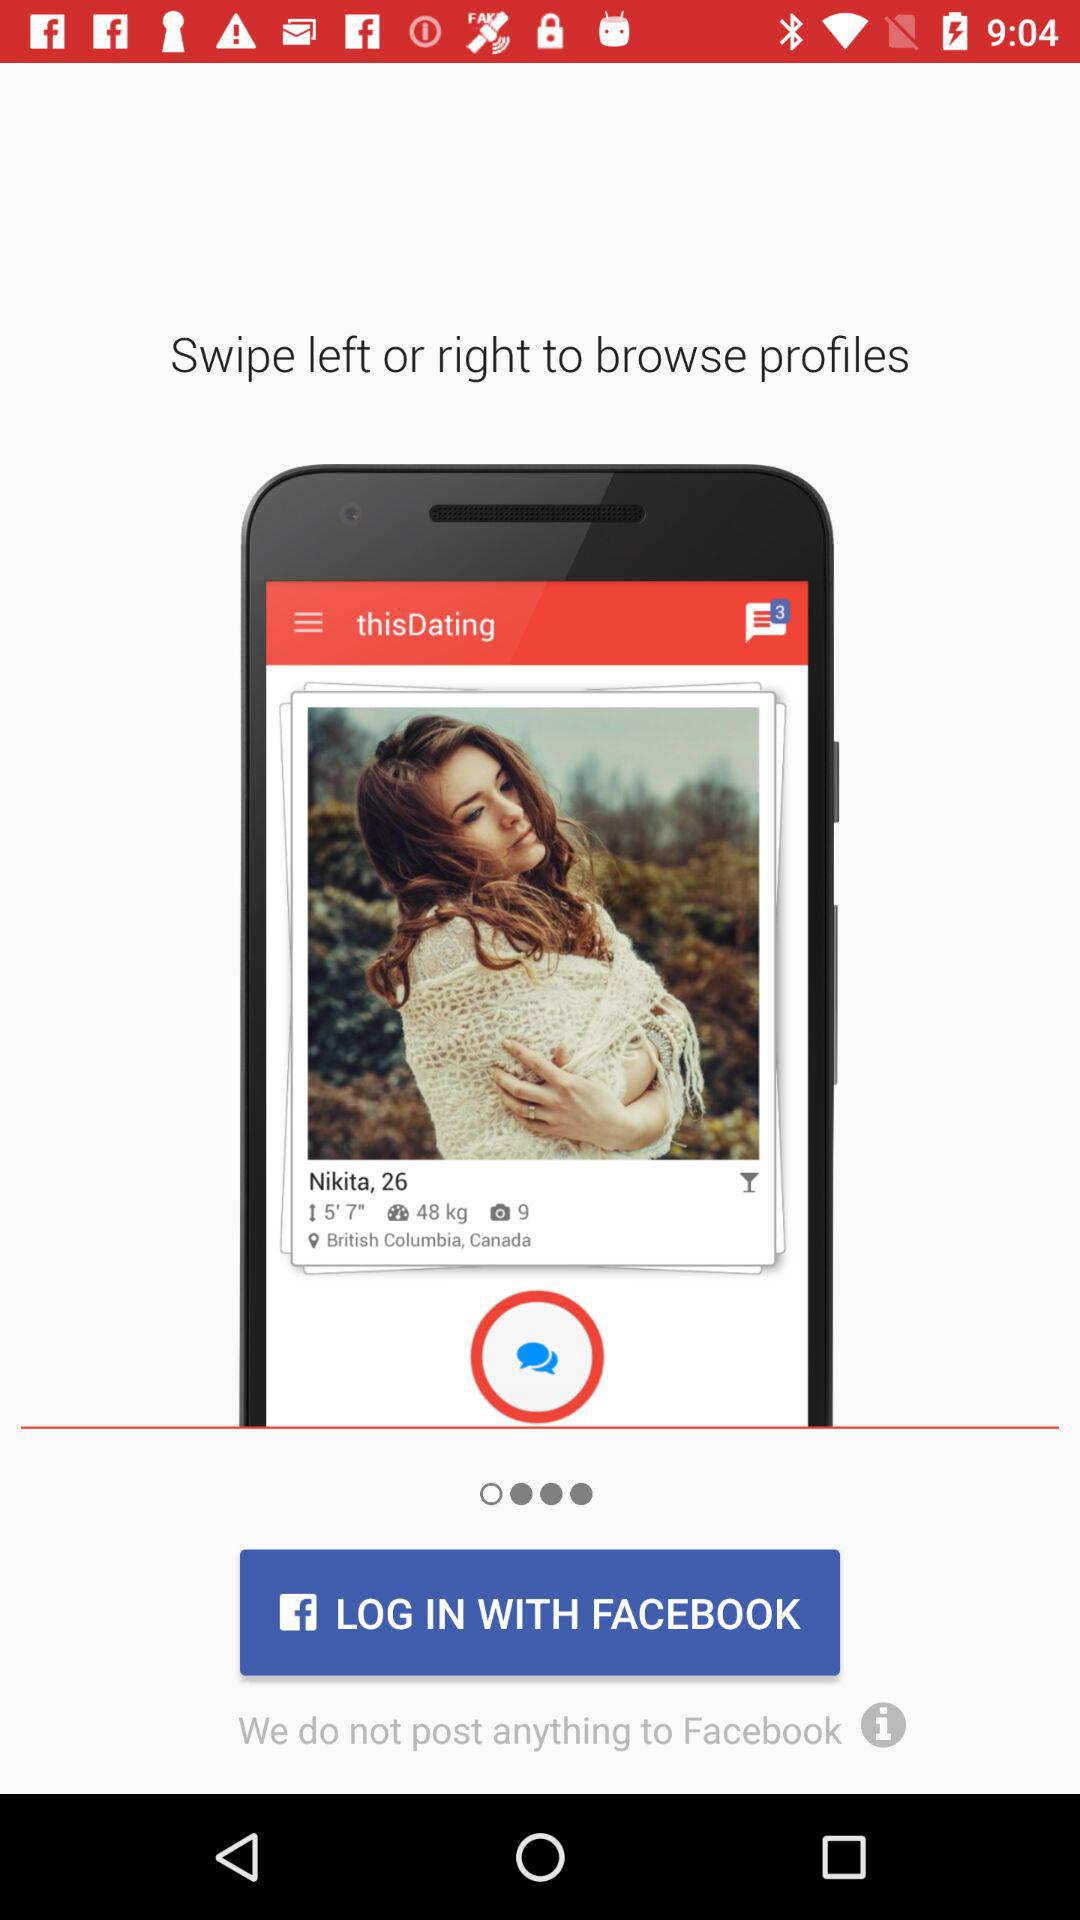What accounts can be used to log in? The account is "FACEBOOK". 